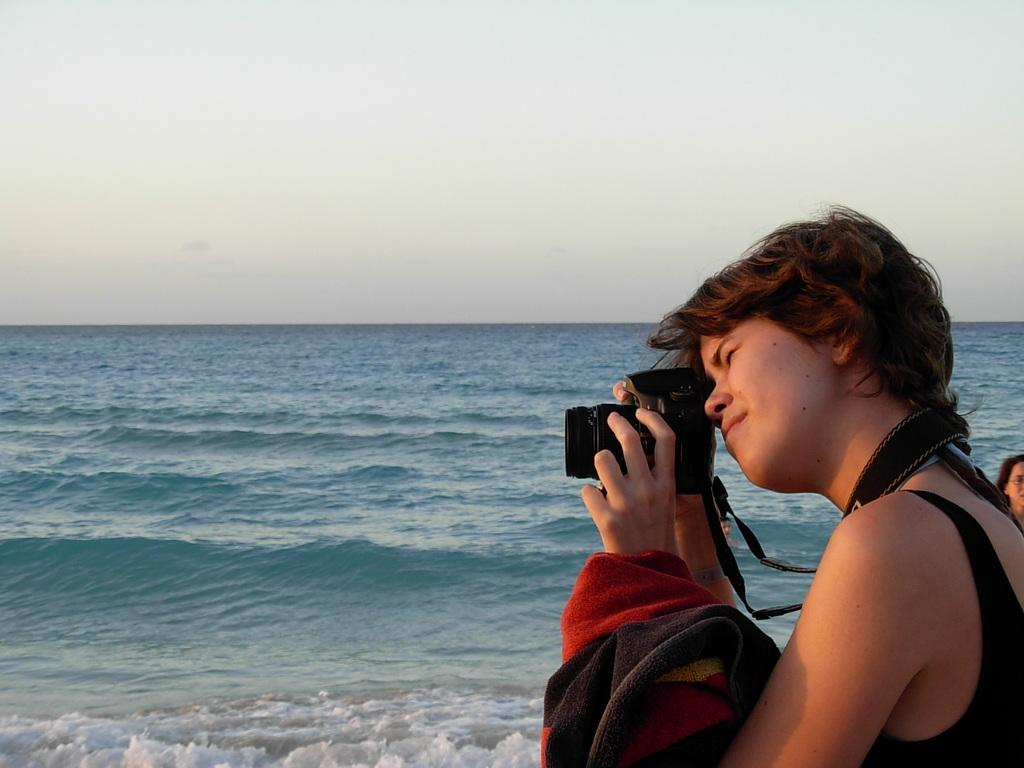Who is the main subject in the image? There is a woman in the image. What is the woman holding in her hand? The woman is holding a camera in her hand. What else is the woman holding? The woman is also holding a cloth. What can be seen in the background of the image? There is an ocean and the sky visible in the background of the image. What type of history lesson is the woman teaching in the image? There is no indication in the image that the woman is teaching a history lesson; she is holding a camera and a cloth. Can you tell me how many kitties are sleeping on the woman's lap in the image? There are no kitties present in the image. 